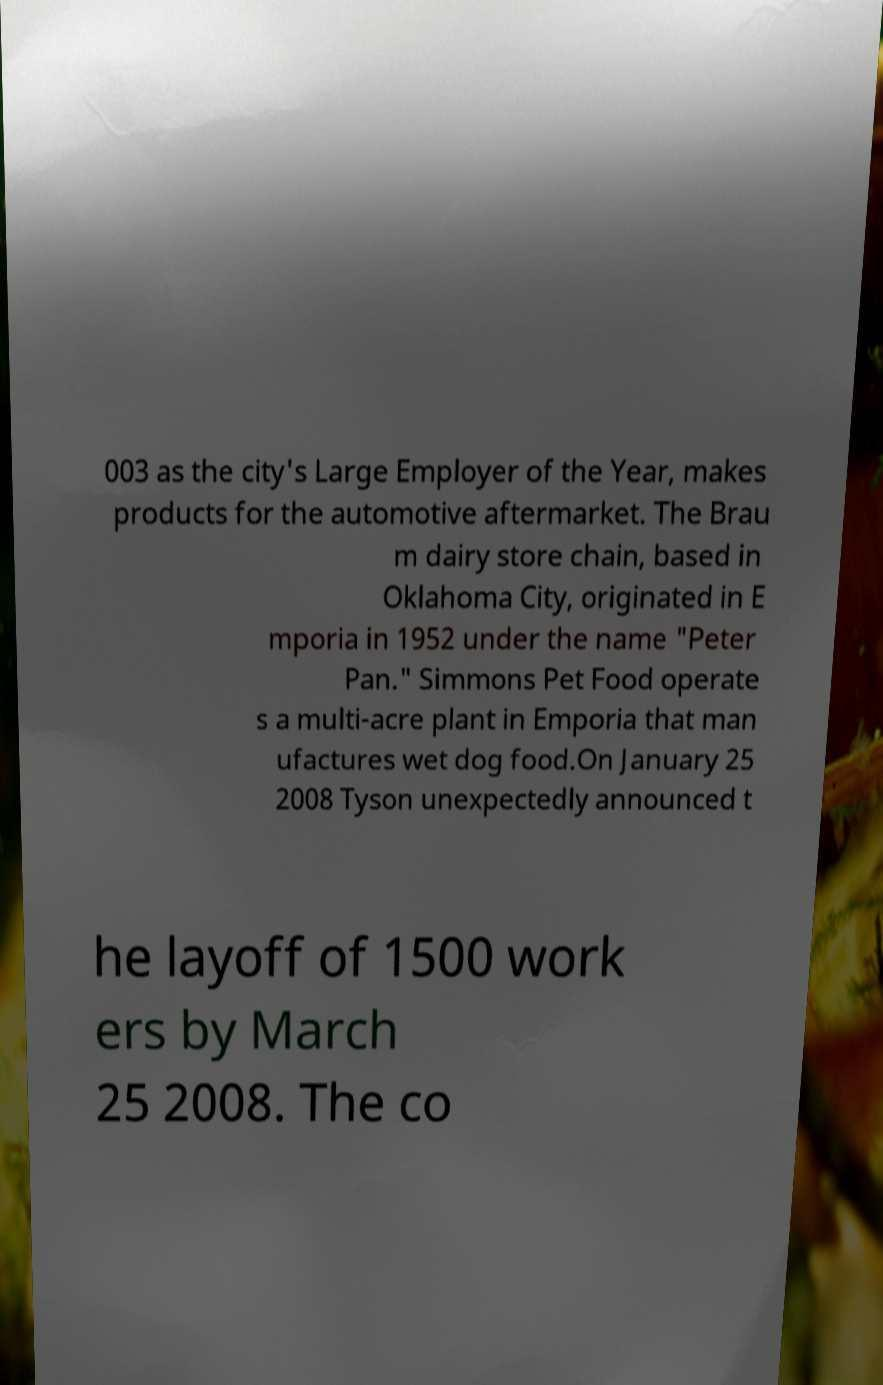I need the written content from this picture converted into text. Can you do that? 003 as the city's Large Employer of the Year, makes products for the automotive aftermarket. The Brau m dairy store chain, based in Oklahoma City, originated in E mporia in 1952 under the name "Peter Pan." Simmons Pet Food operate s a multi-acre plant in Emporia that man ufactures wet dog food.On January 25 2008 Tyson unexpectedly announced t he layoff of 1500 work ers by March 25 2008. The co 